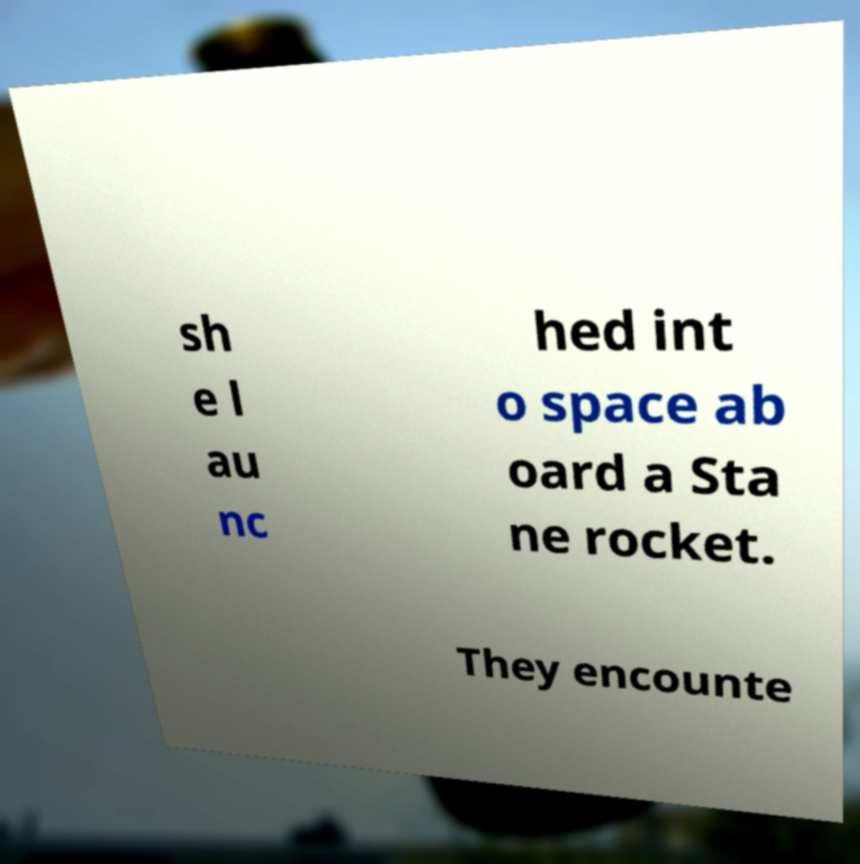There's text embedded in this image that I need extracted. Can you transcribe it verbatim? sh e l au nc hed int o space ab oard a Sta ne rocket. They encounte 